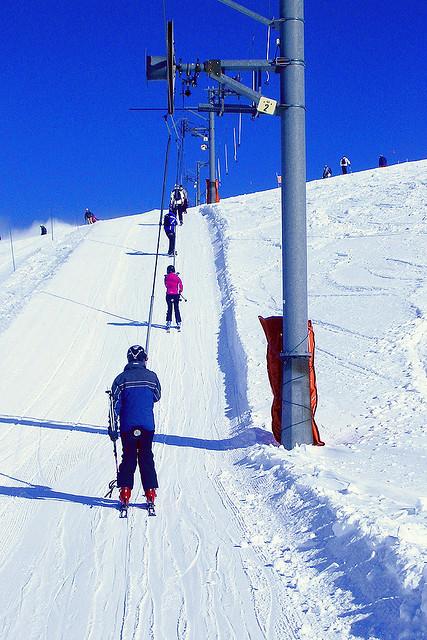What is on the ground?
Be succinct. Snow. Is this a ski tow?
Quick response, please. Yes. Is it a good day for skiing?
Concise answer only. Yes. 